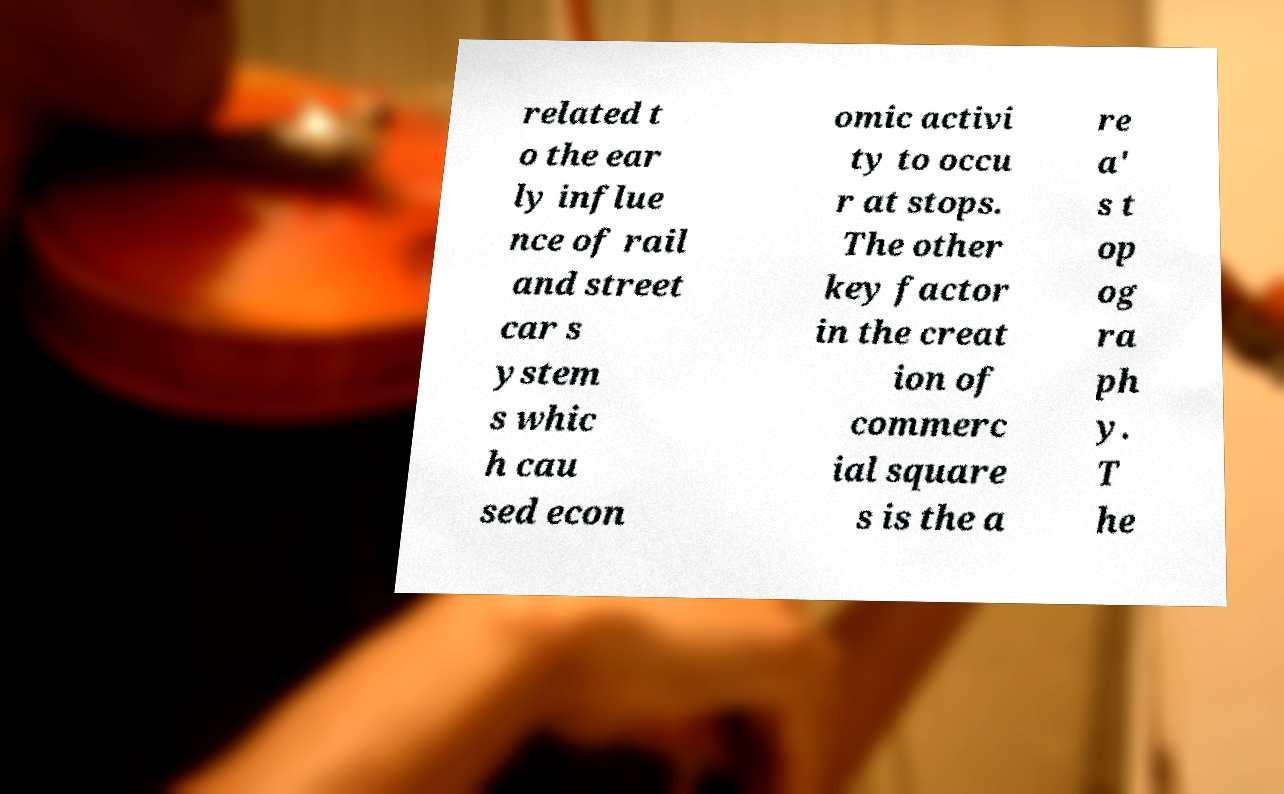There's text embedded in this image that I need extracted. Can you transcribe it verbatim? related t o the ear ly influe nce of rail and street car s ystem s whic h cau sed econ omic activi ty to occu r at stops. The other key factor in the creat ion of commerc ial square s is the a re a' s t op og ra ph y. T he 